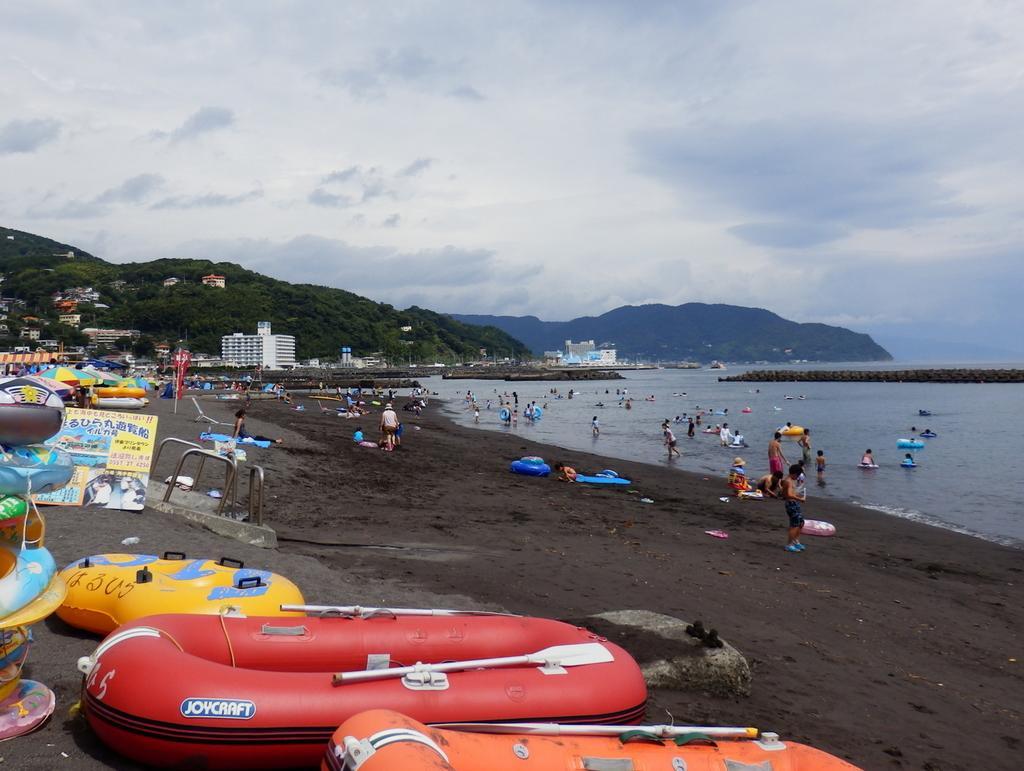Could you give a brief overview of what you see in this image? In the bottom left corner of the image we can see some boats. In the middle of the image few people are standing, sitting, walking and we can see water, trees, buildings and hills. At the top of the image we can see some clouds in the sky. 